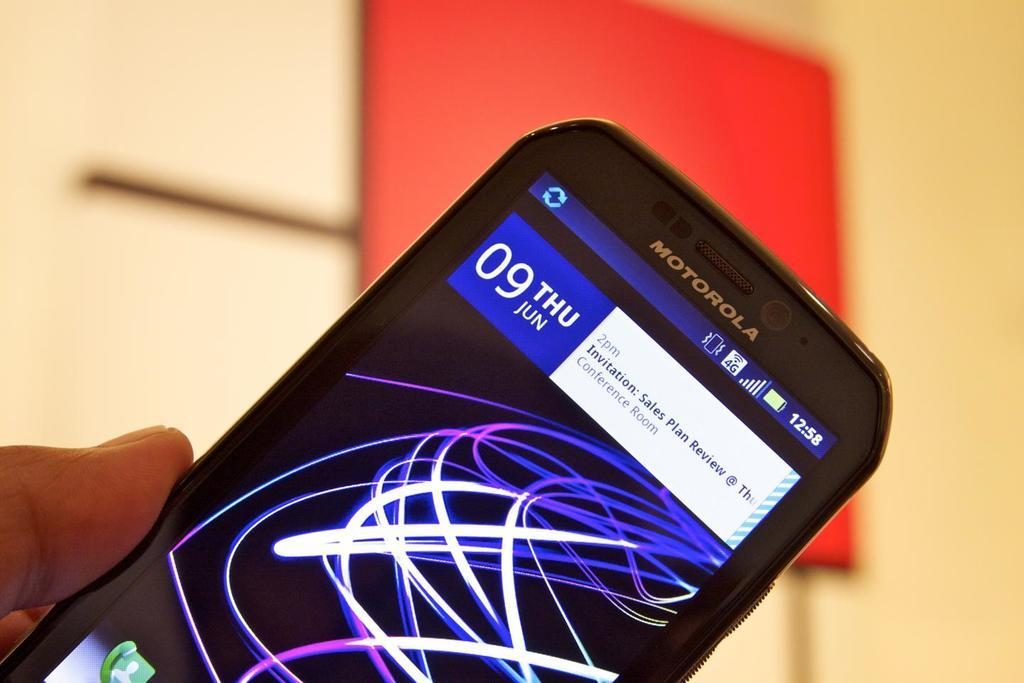<image>
Share a concise interpretation of the image provided. A Motorola device that says it is Thursday the ninth of June. 